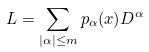<formula> <loc_0><loc_0><loc_500><loc_500>L = \sum _ { | \alpha | \leq m } p _ { \alpha } ( x ) D ^ { \alpha }</formula> 